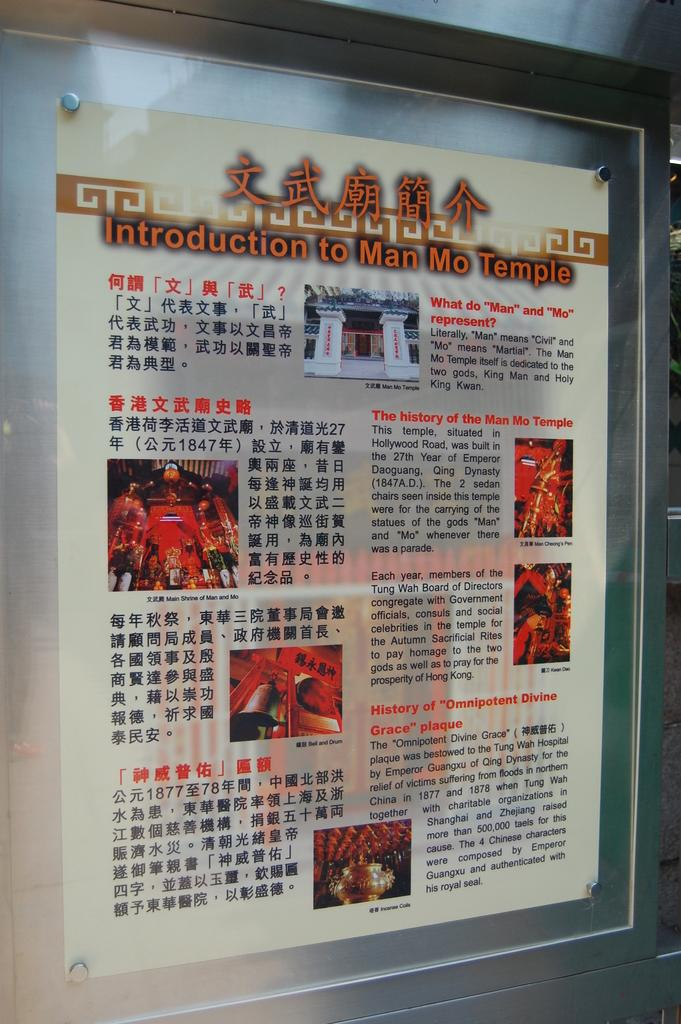<image>
Render a clear and concise summary of the photo. a sign on a building that says 'introduction to man mo temple' 